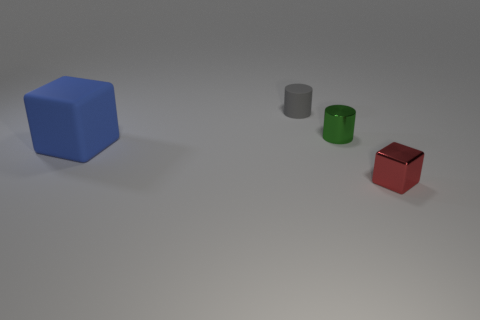Add 3 large brown rubber cubes. How many objects exist? 7 Subtract all large brown shiny blocks. Subtract all small gray rubber cylinders. How many objects are left? 3 Add 4 large matte blocks. How many large matte blocks are left? 5 Add 3 small green cylinders. How many small green cylinders exist? 4 Subtract 0 yellow cylinders. How many objects are left? 4 